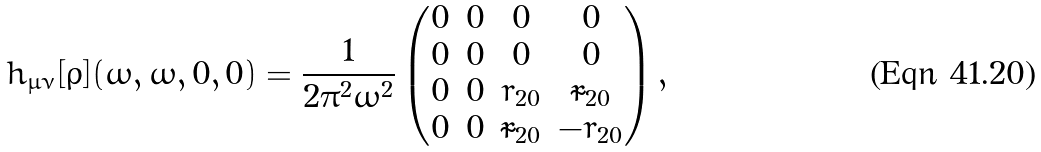Convert formula to latex. <formula><loc_0><loc_0><loc_500><loc_500>h _ { \mu \nu } [ \bar { \rho } ] ( \omega , \omega , 0 , 0 ) = \frac { 1 } { 2 \pi ^ { 2 } \omega ^ { 2 } } \begin{pmatrix} 0 & 0 & 0 & 0 \\ 0 & 0 & 0 & 0 \\ 0 & 0 & r _ { 2 0 } & \tilde { r } _ { 2 0 } \\ 0 & 0 & \tilde { r } _ { 2 0 } & - r _ { 2 0 } \\ \end{pmatrix} ,</formula> 